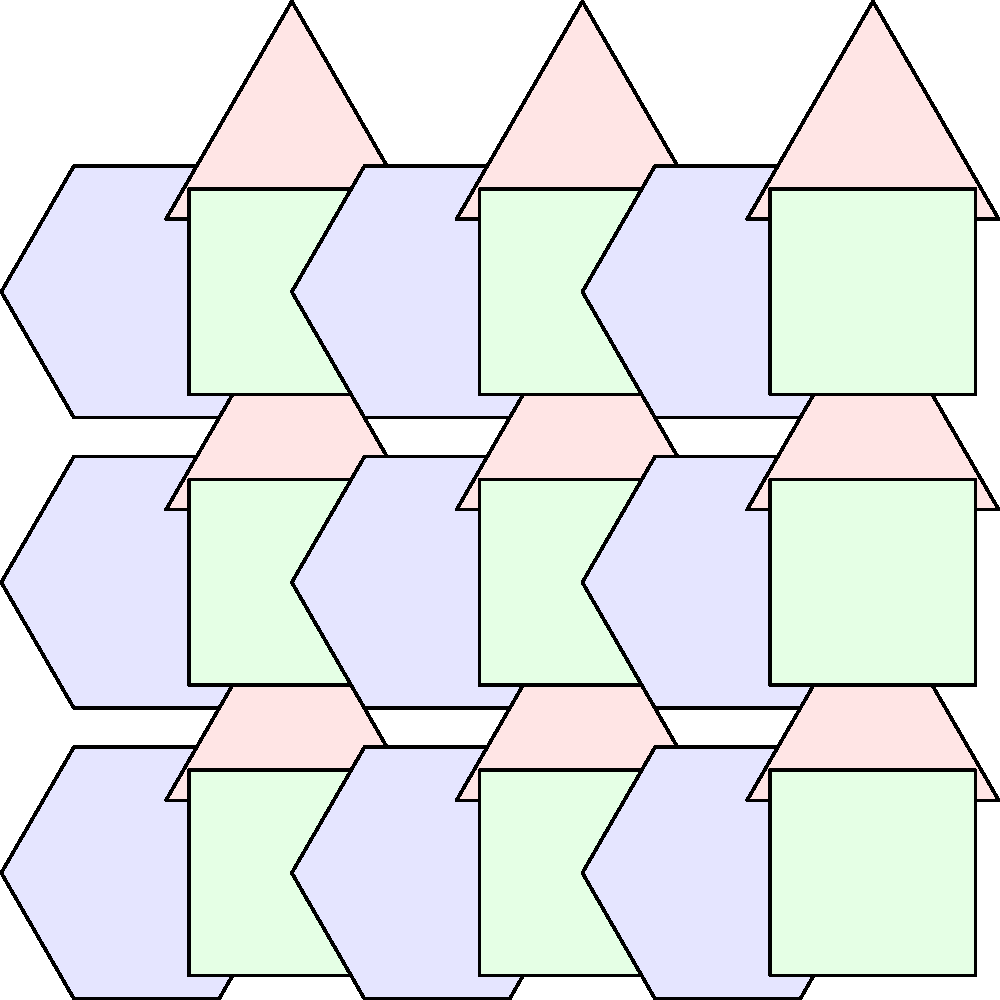You're designing a unique pattern for a new line of eco-friendly product packaging. Using the tessellation shown above, which combines regular hexagons, equilateral triangles, and squares, what is the sum of the interior angles of all the polygons that form a complete repeating unit of this pattern? To solve this problem, let's break it down step-by-step:

1. Identify the repeating unit:
   The pattern repeats with 1 hexagon, 1 triangle, and 1 square.

2. Calculate the interior angles for each polygon:
   - Hexagon: $6 \times 120° = 720°$
   - Equilateral triangle: $3 \times 60° = 180°$
   - Square: $4 \times 90° = 360°$

3. Sum up the interior angles:
   $720° + 180° + 360° = 1260°$

This unique tessellation creates a visually interesting pattern that could be both attractive and symbolic for eco-friendly packaging, as it efficiently uses space without gaps, much like how sustainable packaging aims to minimize waste.
Answer: $1260°$ 